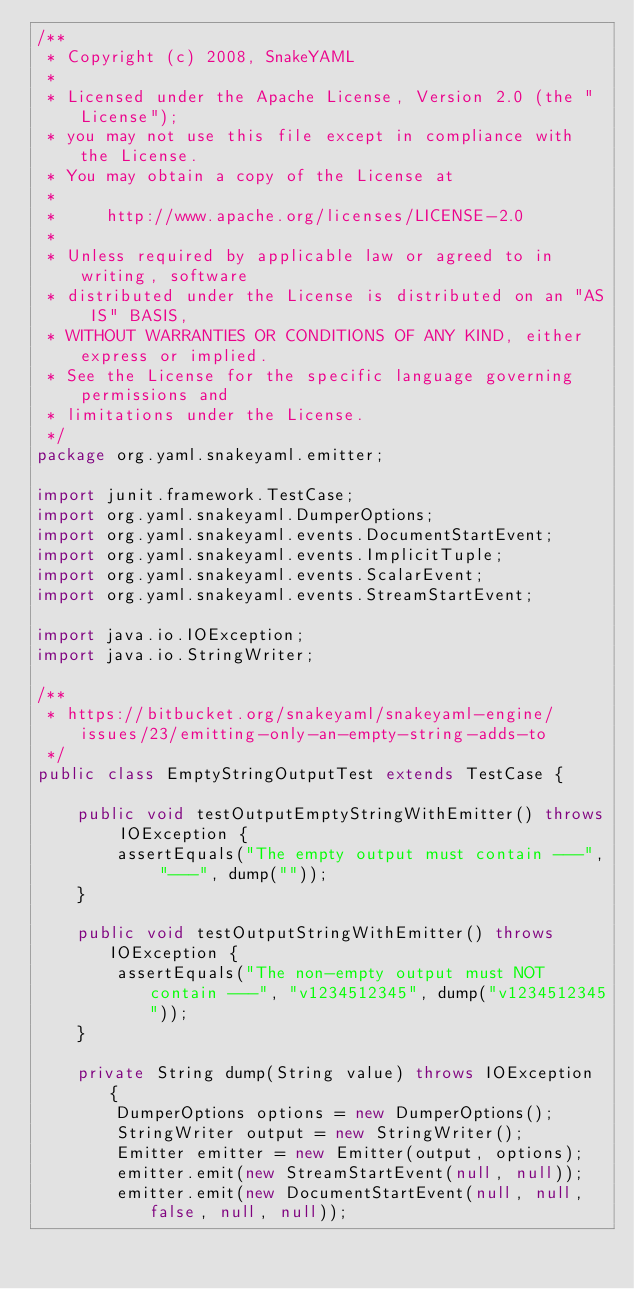Convert code to text. <code><loc_0><loc_0><loc_500><loc_500><_Java_>/**
 * Copyright (c) 2008, SnakeYAML
 *
 * Licensed under the Apache License, Version 2.0 (the "License");
 * you may not use this file except in compliance with the License.
 * You may obtain a copy of the License at
 *
 *     http://www.apache.org/licenses/LICENSE-2.0
 *
 * Unless required by applicable law or agreed to in writing, software
 * distributed under the License is distributed on an "AS IS" BASIS,
 * WITHOUT WARRANTIES OR CONDITIONS OF ANY KIND, either express or implied.
 * See the License for the specific language governing permissions and
 * limitations under the License.
 */
package org.yaml.snakeyaml.emitter;

import junit.framework.TestCase;
import org.yaml.snakeyaml.DumperOptions;
import org.yaml.snakeyaml.events.DocumentStartEvent;
import org.yaml.snakeyaml.events.ImplicitTuple;
import org.yaml.snakeyaml.events.ScalarEvent;
import org.yaml.snakeyaml.events.StreamStartEvent;

import java.io.IOException;
import java.io.StringWriter;

/**
 * https://bitbucket.org/snakeyaml/snakeyaml-engine/issues/23/emitting-only-an-empty-string-adds-to
 */
public class EmptyStringOutputTest extends TestCase {

    public void testOutputEmptyStringWithEmitter() throws IOException {
        assertEquals("The empty output must contain ---", "---", dump(""));
    }

    public void testOutputStringWithEmitter() throws IOException {
        assertEquals("The non-empty output must NOT contain ---", "v1234512345", dump("v1234512345"));
    }

    private String dump(String value) throws IOException {
        DumperOptions options = new DumperOptions();
        StringWriter output = new StringWriter();
        Emitter emitter = new Emitter(output, options);
        emitter.emit(new StreamStartEvent(null, null));
        emitter.emit(new DocumentStartEvent(null, null, false, null, null));</code> 